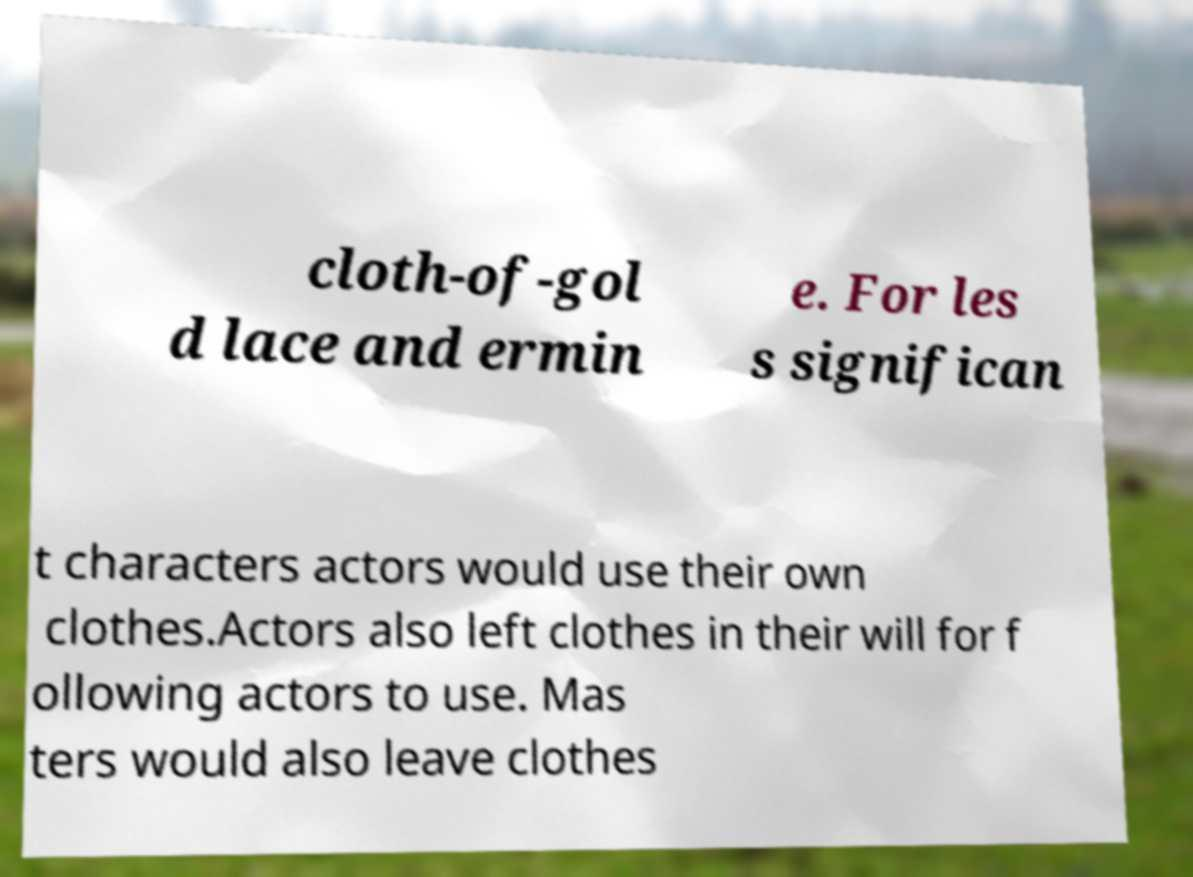Can you accurately transcribe the text from the provided image for me? cloth-of-gol d lace and ermin e. For les s significan t characters actors would use their own clothes.Actors also left clothes in their will for f ollowing actors to use. Mas ters would also leave clothes 